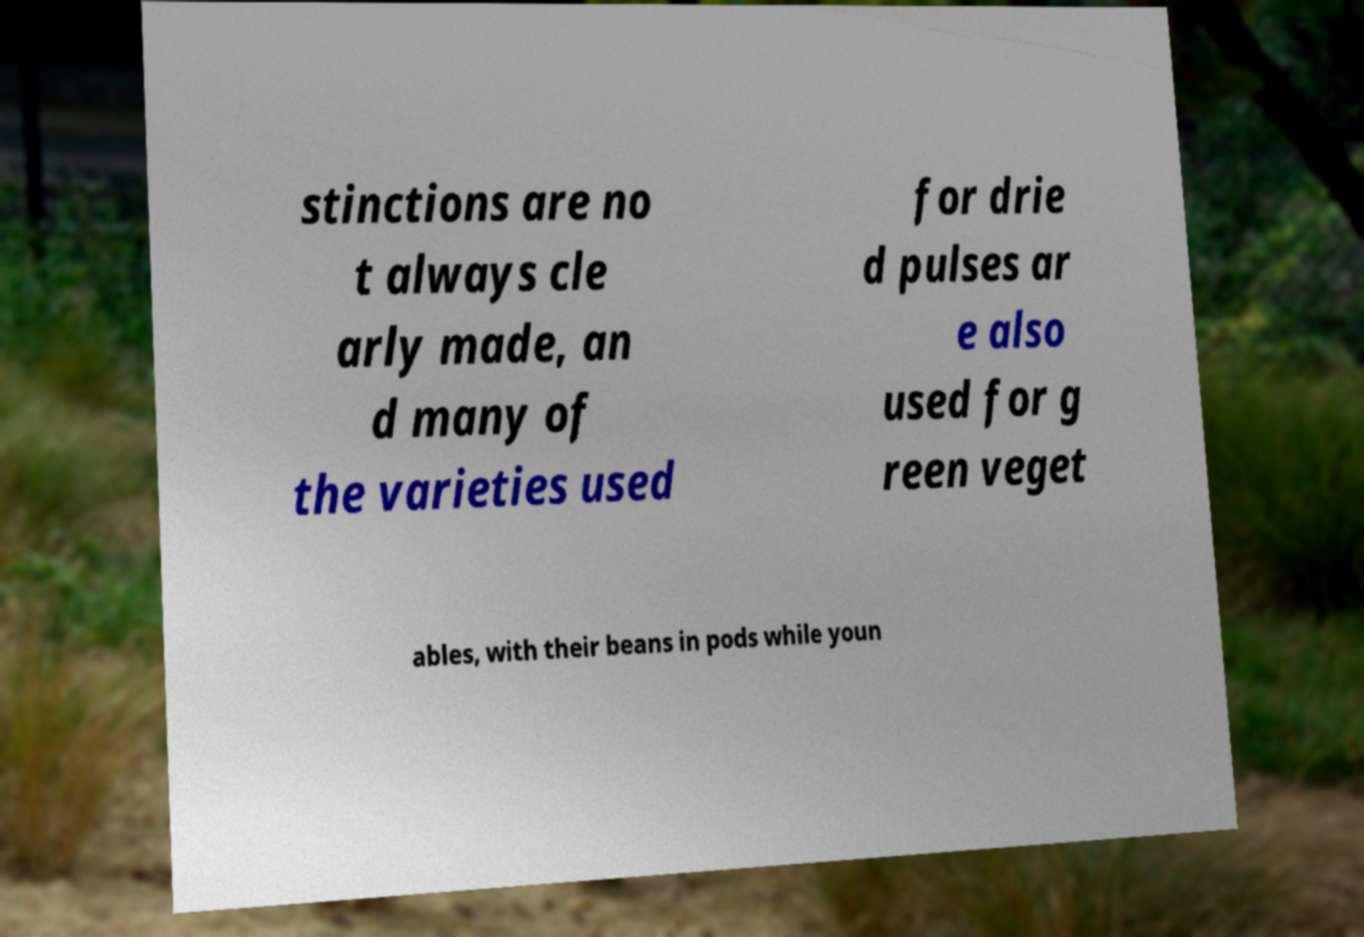Please read and relay the text visible in this image. What does it say? stinctions are no t always cle arly made, an d many of the varieties used for drie d pulses ar e also used for g reen veget ables, with their beans in pods while youn 